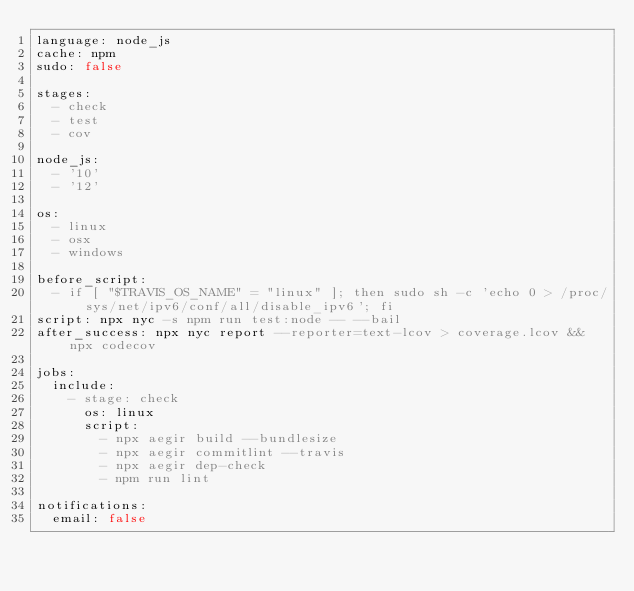<code> <loc_0><loc_0><loc_500><loc_500><_YAML_>language: node_js
cache: npm
sudo: false

stages:
  - check
  - test
  - cov

node_js:
  - '10'
  - '12'

os:
  - linux
  - osx
  - windows

before_script:
  - if [ "$TRAVIS_OS_NAME" = "linux" ]; then sudo sh -c 'echo 0 > /proc/sys/net/ipv6/conf/all/disable_ipv6'; fi
script: npx nyc -s npm run test:node -- --bail
after_success: npx nyc report --reporter=text-lcov > coverage.lcov && npx codecov

jobs:
  include:
    - stage: check
      os: linux
      script:
        - npx aegir build --bundlesize
        - npx aegir commitlint --travis
        - npx aegir dep-check
        - npm run lint

notifications:
  email: false
</code> 